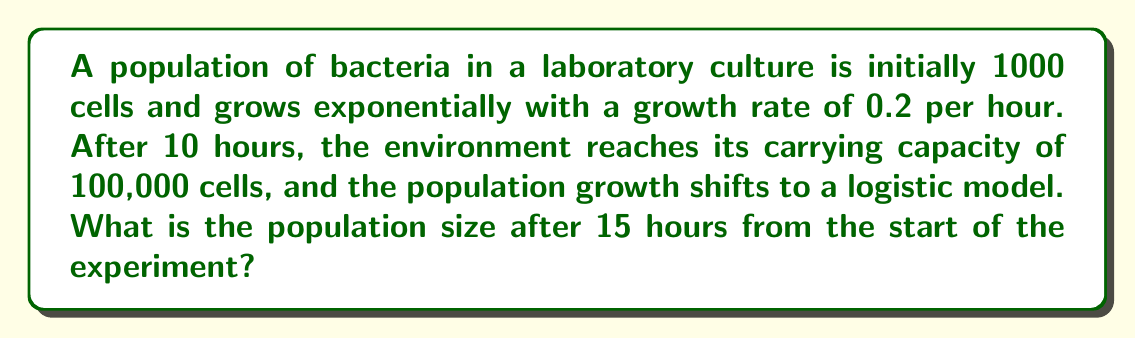Show me your answer to this math problem. Let's approach this problem step-by-step:

1. For the first 10 hours, we use the exponential growth model:
   $$P(t) = P_0 e^{rt}$$
   where $P_0$ is the initial population, $r$ is the growth rate, and $t$ is time.

2. Calculate the population after 10 hours of exponential growth:
   $$P(10) = 1000 \cdot e^{0.2 \cdot 10} = 1000 \cdot e^2 \approx 7389$$

3. For the next 5 hours, we use the logistic growth model:
   $$P(t) = \frac{K}{1 + (\frac{K}{P_0} - 1)e^{-rt}}$$
   where $K$ is the carrying capacity, $P_0$ is the population at $t=0$ for this phase (7389), $r$ is the growth rate, and $t$ is time (5 hours).

4. Substitute the values into the logistic equation:
   $$P(5) = \frac{100000}{1 + (\frac{100000}{7389} - 1)e^{-0.2 \cdot 5}}$$

5. Simplify:
   $$P(5) = \frac{100000}{1 + 12.53 \cdot e^{-1}}$$
   $$P(5) = \frac{100000}{1 + 4.61} = 17857$$

Therefore, after 15 hours (10 hours exponential + 5 hours logistic), the population size is approximately 17,857 cells.
Answer: 17,857 cells 